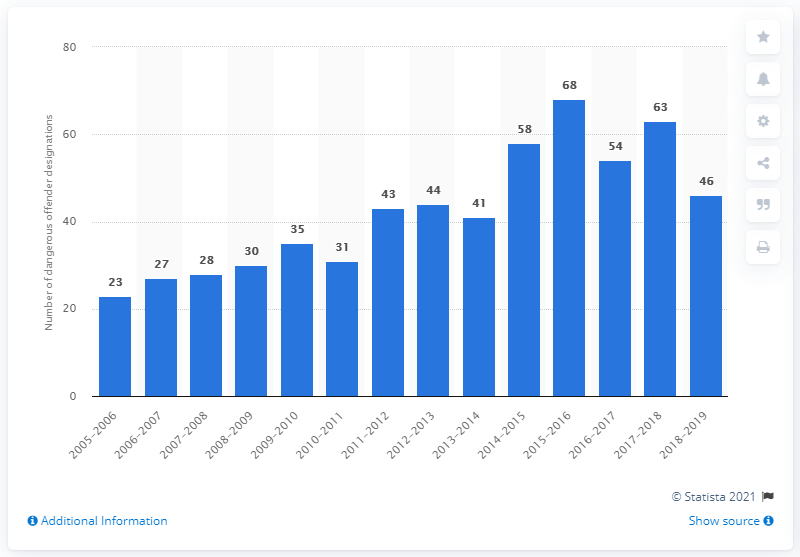Point out several critical features in this image. In the fiscal year of 2019, there were 46 dangerous offender designations in Canada. 